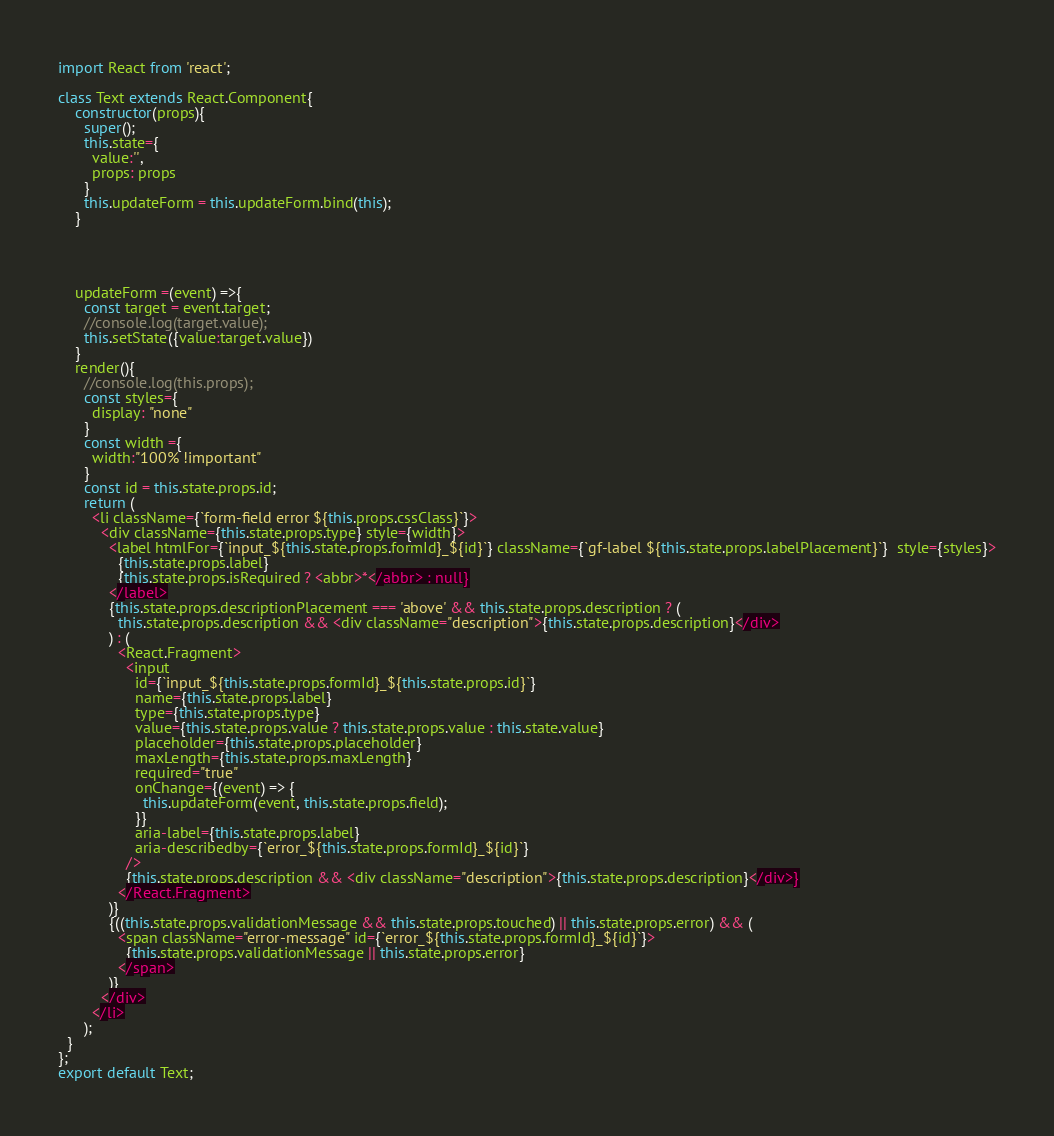Convert code to text. <code><loc_0><loc_0><loc_500><loc_500><_JavaScript_>import React from 'react';

class Text extends React.Component{
    constructor(props){
      super();
      this.state={
        value:'',
        props: props
      }
      this.updateForm = this.updateForm.bind(this);
    }




    updateForm =(event) =>{
      const target = event.target;
      //console.log(target.value);
      this.setState({value:target.value})
    }
    render(){
      //console.log(this.props);
      const styles={
        display: "none"
      }
      const width ={
        width:"100% !important"
      }
      const id = this.state.props.id;
      return (
        <li className={`form-field error ${this.props.cssClass}`}>
          <div className={this.state.props.type} style={width}>
            <label htmlFor={`input_${this.state.props.formId}_${id}`} className={`gf-label ${this.state.props.labelPlacement}`}  style={styles}>
              {this.state.props.label}
              {this.state.props.isRequired ? <abbr>*</abbr> : null}
            </label>
            {this.state.props.descriptionPlacement === 'above' && this.state.props.description ? (
              this.state.props.description && <div className="description">{this.state.props.description}</div>
            ) : (
              <React.Fragment>
                <input
                  id={`input_${this.state.props.formId}_${this.state.props.id}`}
                  name={this.state.props.label}
                  type={this.state.props.type}
                  value={this.state.props.value ? this.state.props.value : this.state.value}
                  placeholder={this.state.props.placeholder}
                  maxLength={this.state.props.maxLength}
                  required="true"
                  onChange={(event) => {
                    this.updateForm(event, this.state.props.field);
                  }}
                  aria-label={this.state.props.label}
                  aria-describedby={`error_${this.state.props.formId}_${id}`}
                />
                {this.state.props.description && <div className="description">{this.state.props.description}</div>}
              </React.Fragment>
            )}
            {((this.state.props.validationMessage && this.state.props.touched) || this.state.props.error) && (
              <span className="error-message" id={`error_${this.state.props.formId}_${id}`}>
                {this.state.props.validationMessage || this.state.props.error}
              </span>
            )}
          </div>
        </li>
      );
  }
};
export default Text;
</code> 